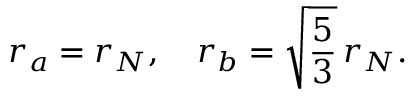<formula> <loc_0><loc_0><loc_500><loc_500>r _ { a } = r _ { N } , \quad r _ { b } = \sqrt { \frac { 5 } { 3 } } \, r _ { N } .</formula> 